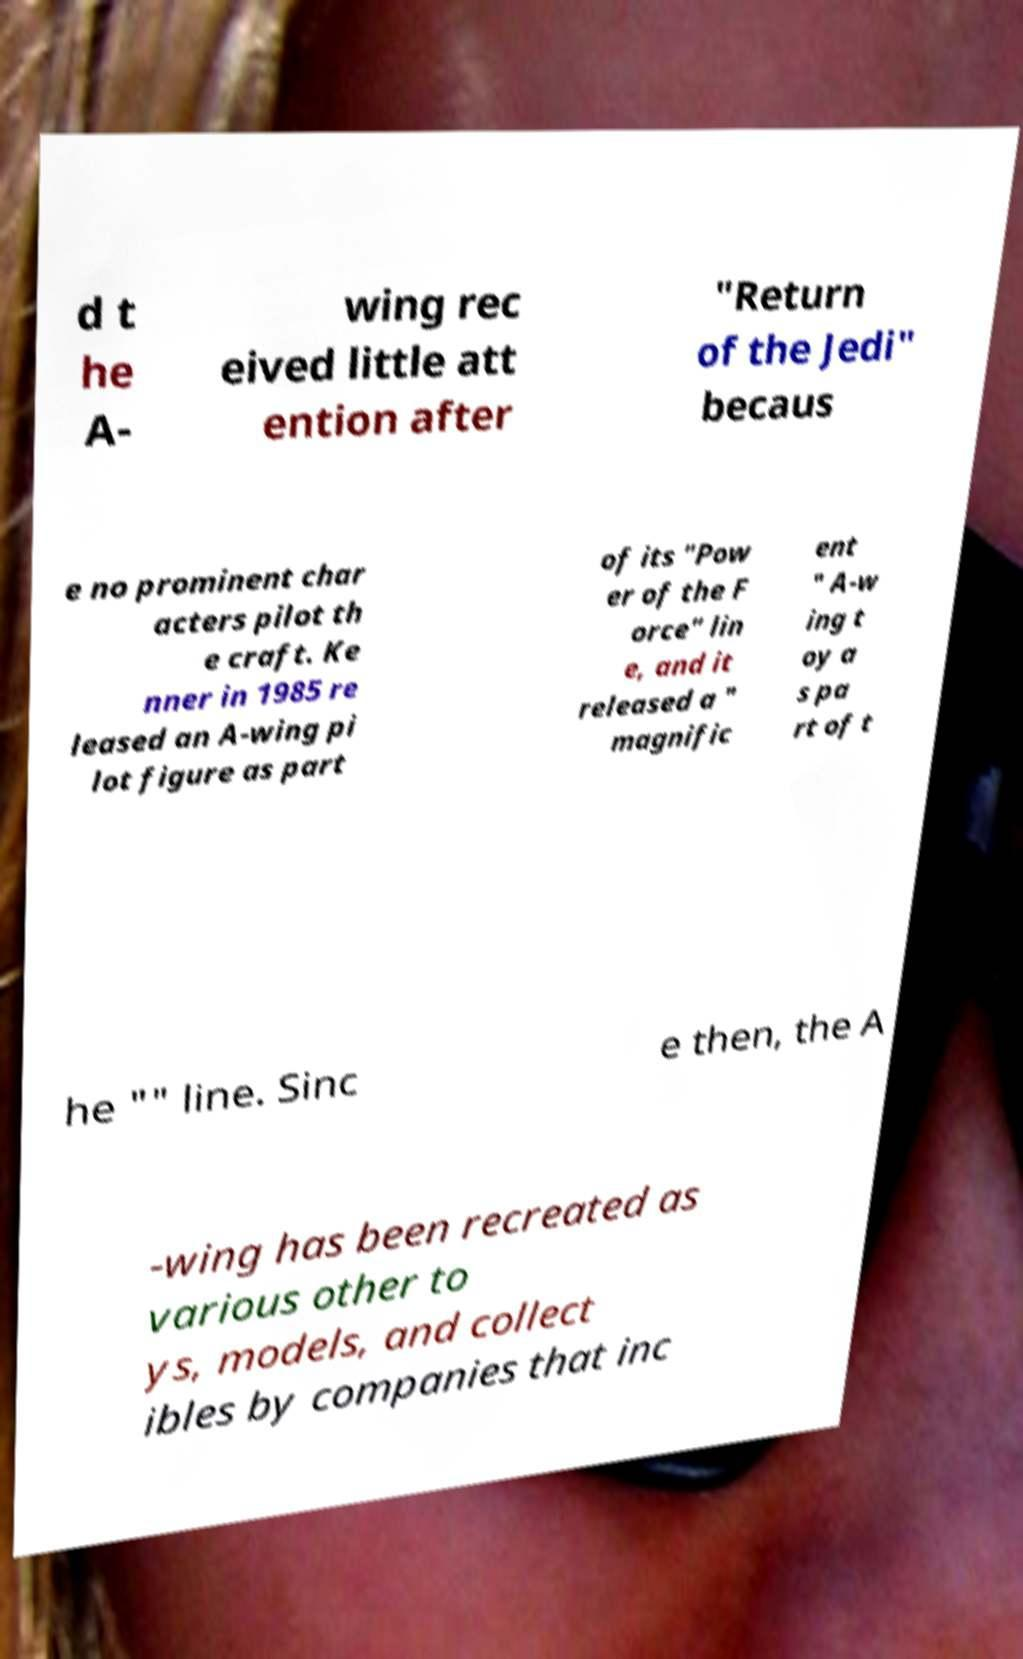What messages or text are displayed in this image? I need them in a readable, typed format. d t he A- wing rec eived little att ention after "Return of the Jedi" becaus e no prominent char acters pilot th e craft. Ke nner in 1985 re leased an A-wing pi lot figure as part of its "Pow er of the F orce" lin e, and it released a " magnific ent " A-w ing t oy a s pa rt of t he "" line. Sinc e then, the A -wing has been recreated as various other to ys, models, and collect ibles by companies that inc 